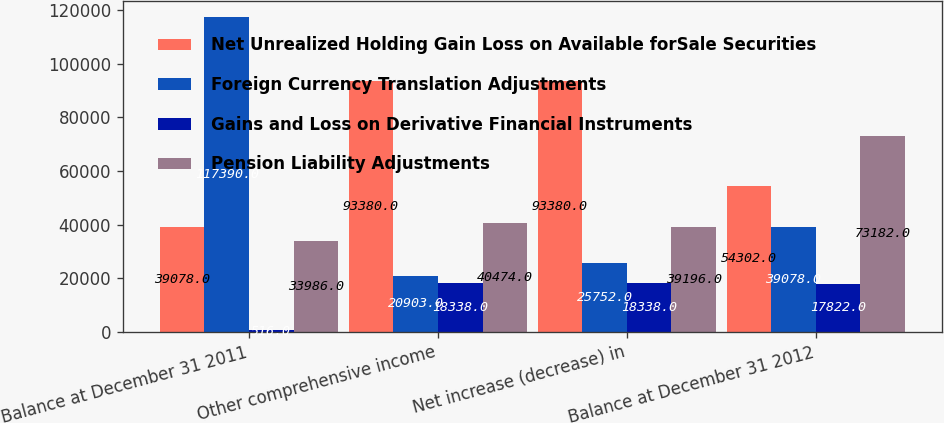<chart> <loc_0><loc_0><loc_500><loc_500><stacked_bar_chart><ecel><fcel>Balance at December 31 2011<fcel>Other comprehensive income<fcel>Net increase (decrease) in<fcel>Balance at December 31 2012<nl><fcel>Net Unrealized Holding Gain Loss on Available forSale Securities<fcel>39078<fcel>93380<fcel>93380<fcel>54302<nl><fcel>Foreign Currency Translation Adjustments<fcel>117390<fcel>20903<fcel>25752<fcel>39078<nl><fcel>Gains and Loss on Derivative Financial Instruments<fcel>516<fcel>18338<fcel>18338<fcel>17822<nl><fcel>Pension Liability Adjustments<fcel>33986<fcel>40474<fcel>39196<fcel>73182<nl></chart> 